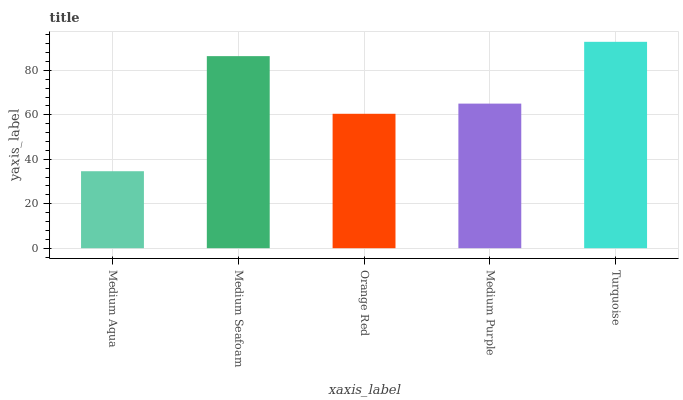Is Medium Seafoam the minimum?
Answer yes or no. No. Is Medium Seafoam the maximum?
Answer yes or no. No. Is Medium Seafoam greater than Medium Aqua?
Answer yes or no. Yes. Is Medium Aqua less than Medium Seafoam?
Answer yes or no. Yes. Is Medium Aqua greater than Medium Seafoam?
Answer yes or no. No. Is Medium Seafoam less than Medium Aqua?
Answer yes or no. No. Is Medium Purple the high median?
Answer yes or no. Yes. Is Medium Purple the low median?
Answer yes or no. Yes. Is Medium Aqua the high median?
Answer yes or no. No. Is Medium Seafoam the low median?
Answer yes or no. No. 